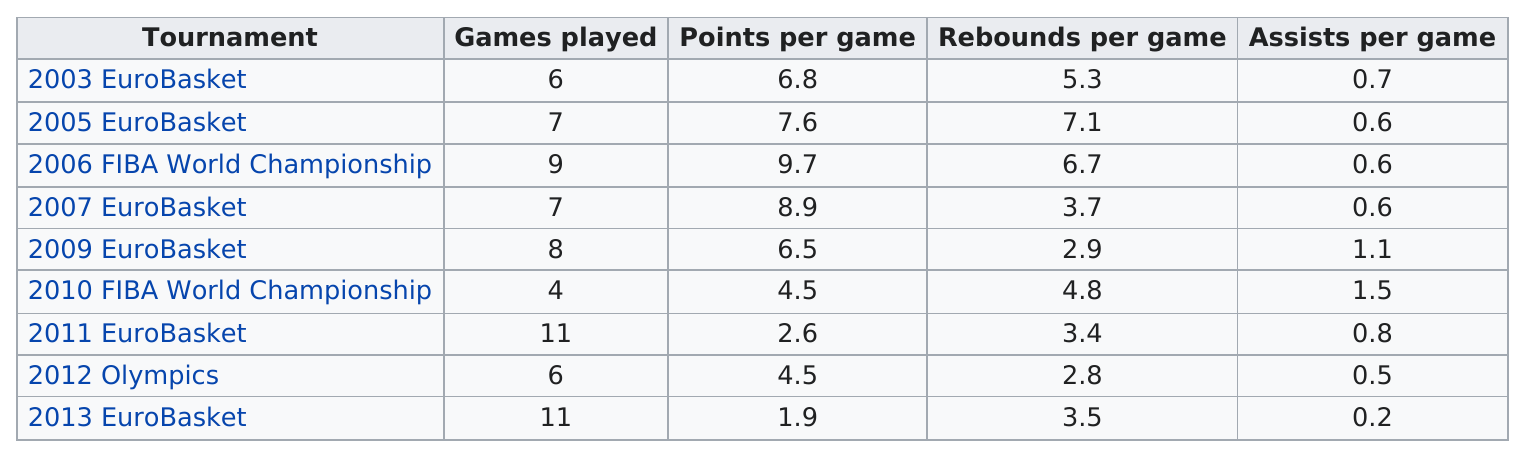Draw attention to some important aspects in this diagram. The team had the least rebounds per game in the 2012 Olympics. The 2006 FIBA World Championship had the most points per game out of all the tournaments. The 2005 EuroBasket tournament did not feature any games with less than 7 rebounds per game. During the 2013 EuroBasket tournament, Florent averaged the least number of points per game. The team played in a maximum of 9 games in how many tournaments? 3 or more. 